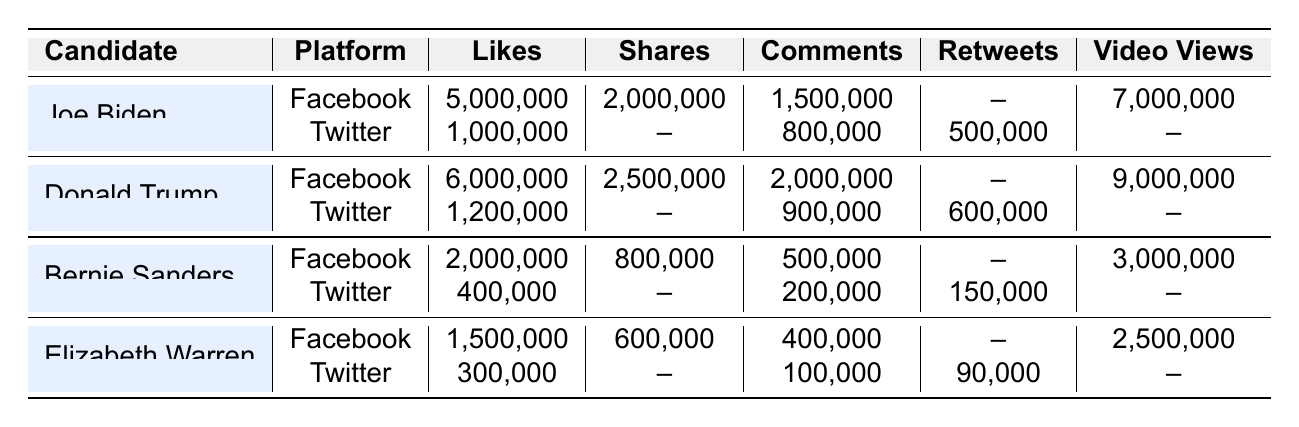What candidate had the highest number of likes on Facebook? By looking at the "Likes" column under the Facebook platform, Joe Biden has 5,000,000 likes, while Donald Trump has 6,000,000 likes, which is higher. Hence, the candidate with the highest likes is Donald Trump.
Answer: Donald Trump How many total comments did Joe Biden receive across both platforms? Joe Biden has 1,500,000 comments on Facebook and 800,000 comments on Twitter. Adding these two values gives 1,500,000 + 800,000 = 2,300,000 comments in total.
Answer: 2,300,000 Which candidate received more total video views, Joe Biden or Donald Trump? Joe Biden received 7,000,000 video views on Facebook while Donald Trump received 9,000,000 video views. Therefore, Donald Trump has more video views.
Answer: Donald Trump Did Bernie Sanders have more likes on Facebook or Twitter? Bernie Sanders has 2,000,000 likes on Facebook and 400,000 likes on Twitter. Comparing these two numbers shows that 2,000,000 is greater than 400,000, therefore he had more likes on Facebook.
Answer: Yes, more likes on Facebook What is the difference in shares between Donald Trump on Facebook and Joe Biden on Twitter? Donald Trump has 2,500,000 shares on Facebook, and Joe Biden has no shares on Twitter (noted as null). The difference is therefore 2,500,000 - 0 = 2,500,000 shares.
Answer: 2,500,000 shares What is the average number of likes across all candidates on Twitter? Joe Biden has 1,000,000 likes, Donald Trump has 1,200,000 likes, Bernie Sanders has 400,000 likes, and Elizabeth Warren has 300,000 likes. The total is 1,000,000 + 1,200,000 + 400,000 + 300,000 = 2,900,000. Dividing by 4 candidates gives 2,900,000 / 4 = 725,000 likes on average.
Answer: 725,000 likes Which platform, Facebook or Twitter, had more overall comments across all candidates? Summing comments on Facebook gives 1,500,000 + 2,000,000 + 500,000 + 400,000 = 4,400,000. For Twitter, it's 800,000 + 900,000 + 200,000 + 100,000 = 2,100,000. Comparing totals shows Facebook has more comments.
Answer: Facebook had more comments Who had the highest number of retweets, and how many did they have? Looking at the retweets column, Donald Trump has 600,000 retweets on Twitter, while others have fewer or none. Therefore, he had the highest retweet count.
Answer: Donald Trump, 600,000 retweets What is the total combined number of likes and video views for Elizabeth Warren? Elizabeth Warren has 1,500,000 likes on Facebook and 2,500,000 video views on Facebook. Adding these results gives 1,500,000 + 2,500,000 = 4,000,000.
Answer: 4,000,000 How many shares did Bernie Sanders receive on Facebook? Referring to the Facebook row for Bernie Sanders, it shows he received 800,000 shares.
Answer: 800,000 shares 